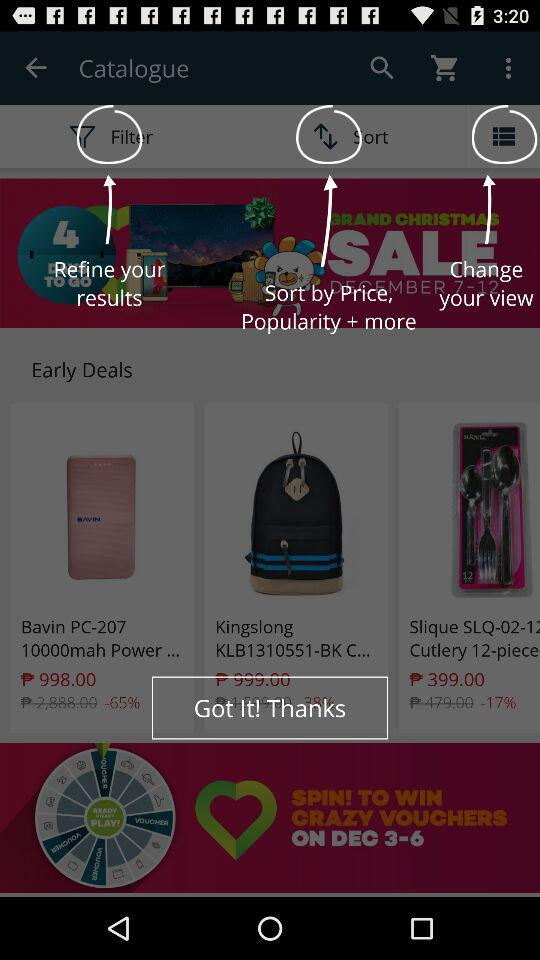How many items are on sale?
Answer the question using a single word or phrase. 3 